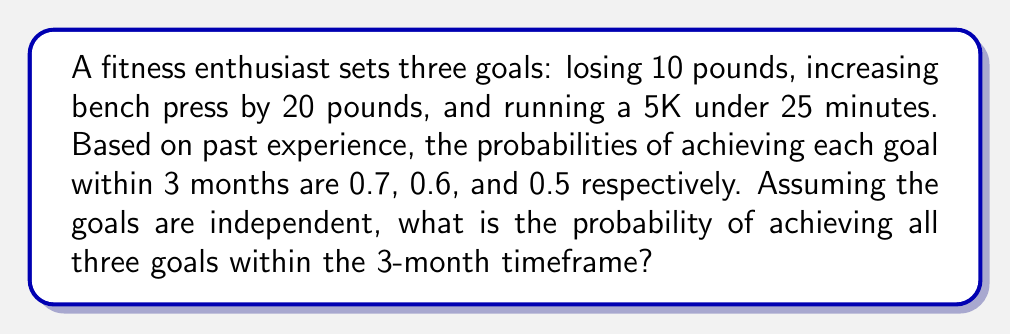Help me with this question. To solve this problem, we need to follow these steps:

1. Identify the probabilities for each goal:
   - Losing 10 pounds: $P(A) = 0.7$
   - Increasing bench press by 20 pounds: $P(B) = 0.6$
   - Running a 5K under 25 minutes: $P(C) = 0.5$

2. Recognize that we need to find the probability of all three events occurring together.

3. Since the goals are independent, we can use the multiplication rule of probability:
   $P(A \text{ and } B \text{ and } C) = P(A) \times P(B) \times P(C)$

4. Substitute the values:
   $P(\text{all goals}) = 0.7 \times 0.6 \times 0.5$

5. Calculate the result:
   $P(\text{all goals}) = 0.21$

Therefore, the probability of achieving all three fitness goals within the 3-month timeframe is 0.21 or 21%.
Answer: 0.21 